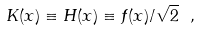<formula> <loc_0><loc_0><loc_500><loc_500>K ( x ) \equiv H ( x ) \equiv f ( x ) / \sqrt { 2 } \ ,</formula> 